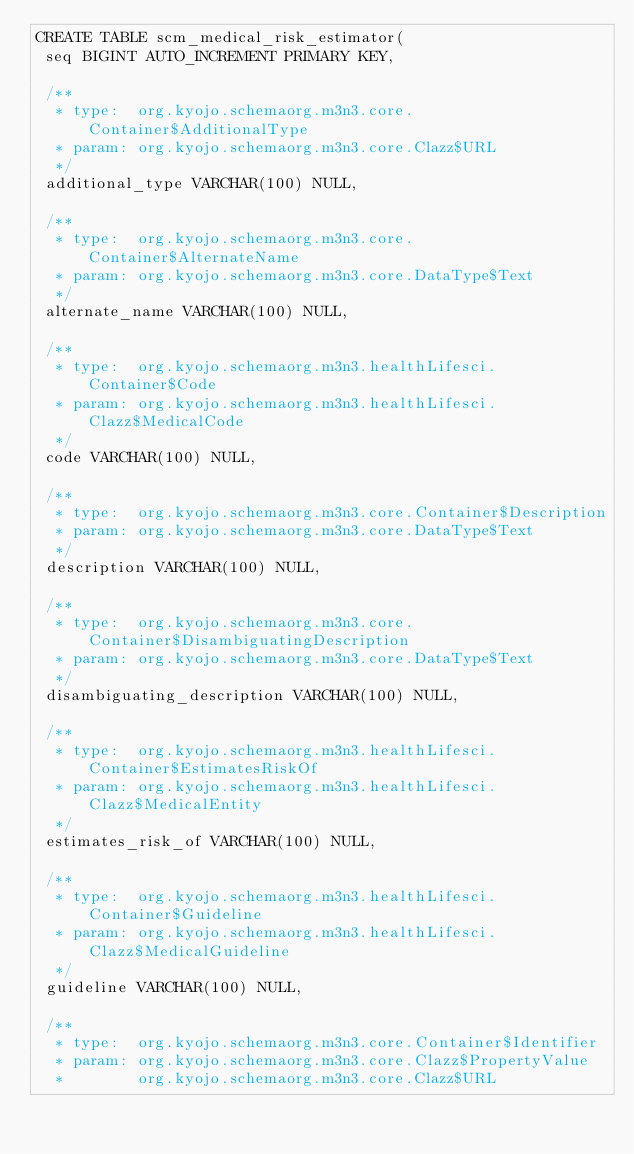<code> <loc_0><loc_0><loc_500><loc_500><_SQL_>CREATE TABLE scm_medical_risk_estimator(
 seq BIGINT AUTO_INCREMENT PRIMARY KEY,

 /**
  * type:  org.kyojo.schemaorg.m3n3.core.Container$AdditionalType
  * param: org.kyojo.schemaorg.m3n3.core.Clazz$URL
  */
 additional_type VARCHAR(100) NULL,

 /**
  * type:  org.kyojo.schemaorg.m3n3.core.Container$AlternateName
  * param: org.kyojo.schemaorg.m3n3.core.DataType$Text
  */
 alternate_name VARCHAR(100) NULL,

 /**
  * type:  org.kyojo.schemaorg.m3n3.healthLifesci.Container$Code
  * param: org.kyojo.schemaorg.m3n3.healthLifesci.Clazz$MedicalCode
  */
 code VARCHAR(100) NULL,

 /**
  * type:  org.kyojo.schemaorg.m3n3.core.Container$Description
  * param: org.kyojo.schemaorg.m3n3.core.DataType$Text
  */
 description VARCHAR(100) NULL,

 /**
  * type:  org.kyojo.schemaorg.m3n3.core.Container$DisambiguatingDescription
  * param: org.kyojo.schemaorg.m3n3.core.DataType$Text
  */
 disambiguating_description VARCHAR(100) NULL,

 /**
  * type:  org.kyojo.schemaorg.m3n3.healthLifesci.Container$EstimatesRiskOf
  * param: org.kyojo.schemaorg.m3n3.healthLifesci.Clazz$MedicalEntity
  */
 estimates_risk_of VARCHAR(100) NULL,

 /**
  * type:  org.kyojo.schemaorg.m3n3.healthLifesci.Container$Guideline
  * param: org.kyojo.schemaorg.m3n3.healthLifesci.Clazz$MedicalGuideline
  */
 guideline VARCHAR(100) NULL,

 /**
  * type:  org.kyojo.schemaorg.m3n3.core.Container$Identifier
  * param: org.kyojo.schemaorg.m3n3.core.Clazz$PropertyValue
  *        org.kyojo.schemaorg.m3n3.core.Clazz$URL</code> 